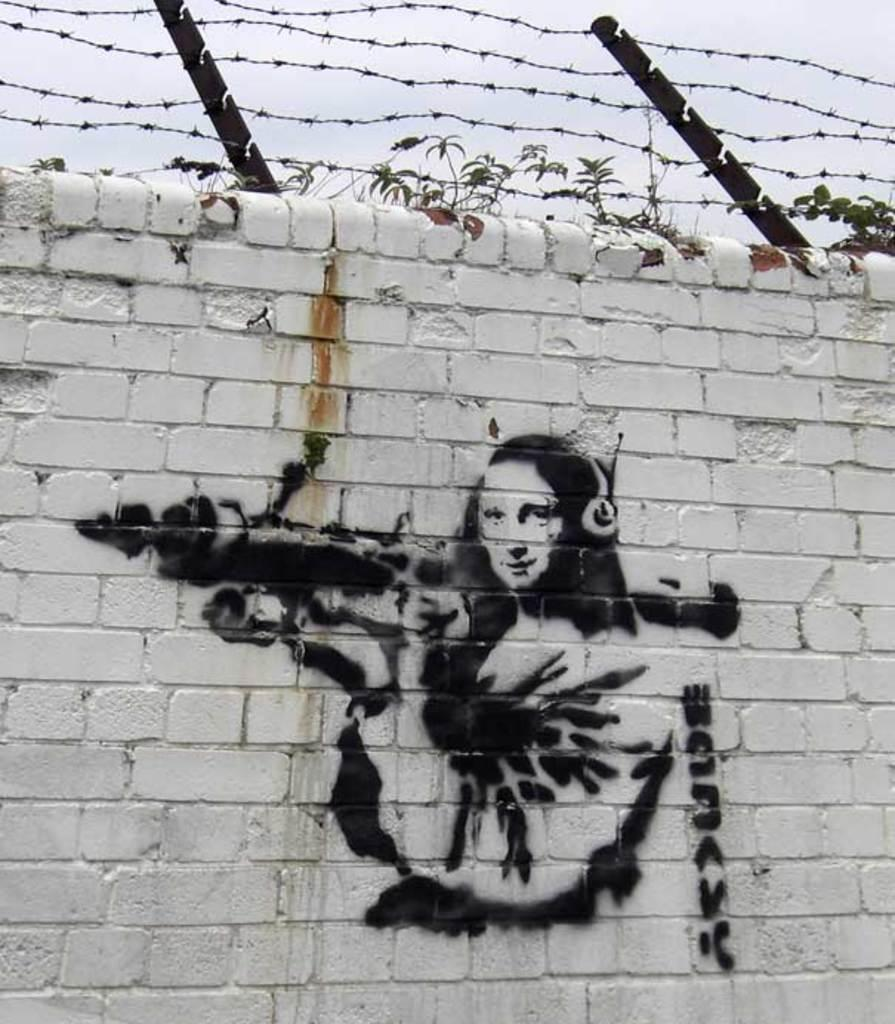What type of artwork can be seen on the wall in the image? There are paintings on the wall in the image. What can be seen at the top of the image? Plants and a fence are visible at the top of the image. What is visible in the background of the image? The sky is visible in the background of the image. How does the fence show respect in the image? The fence does not show respect in the image; it is simply a fence. What type of act is being performed by the plants in the image? There is no act being performed by the plants in the image; they are stationary. 